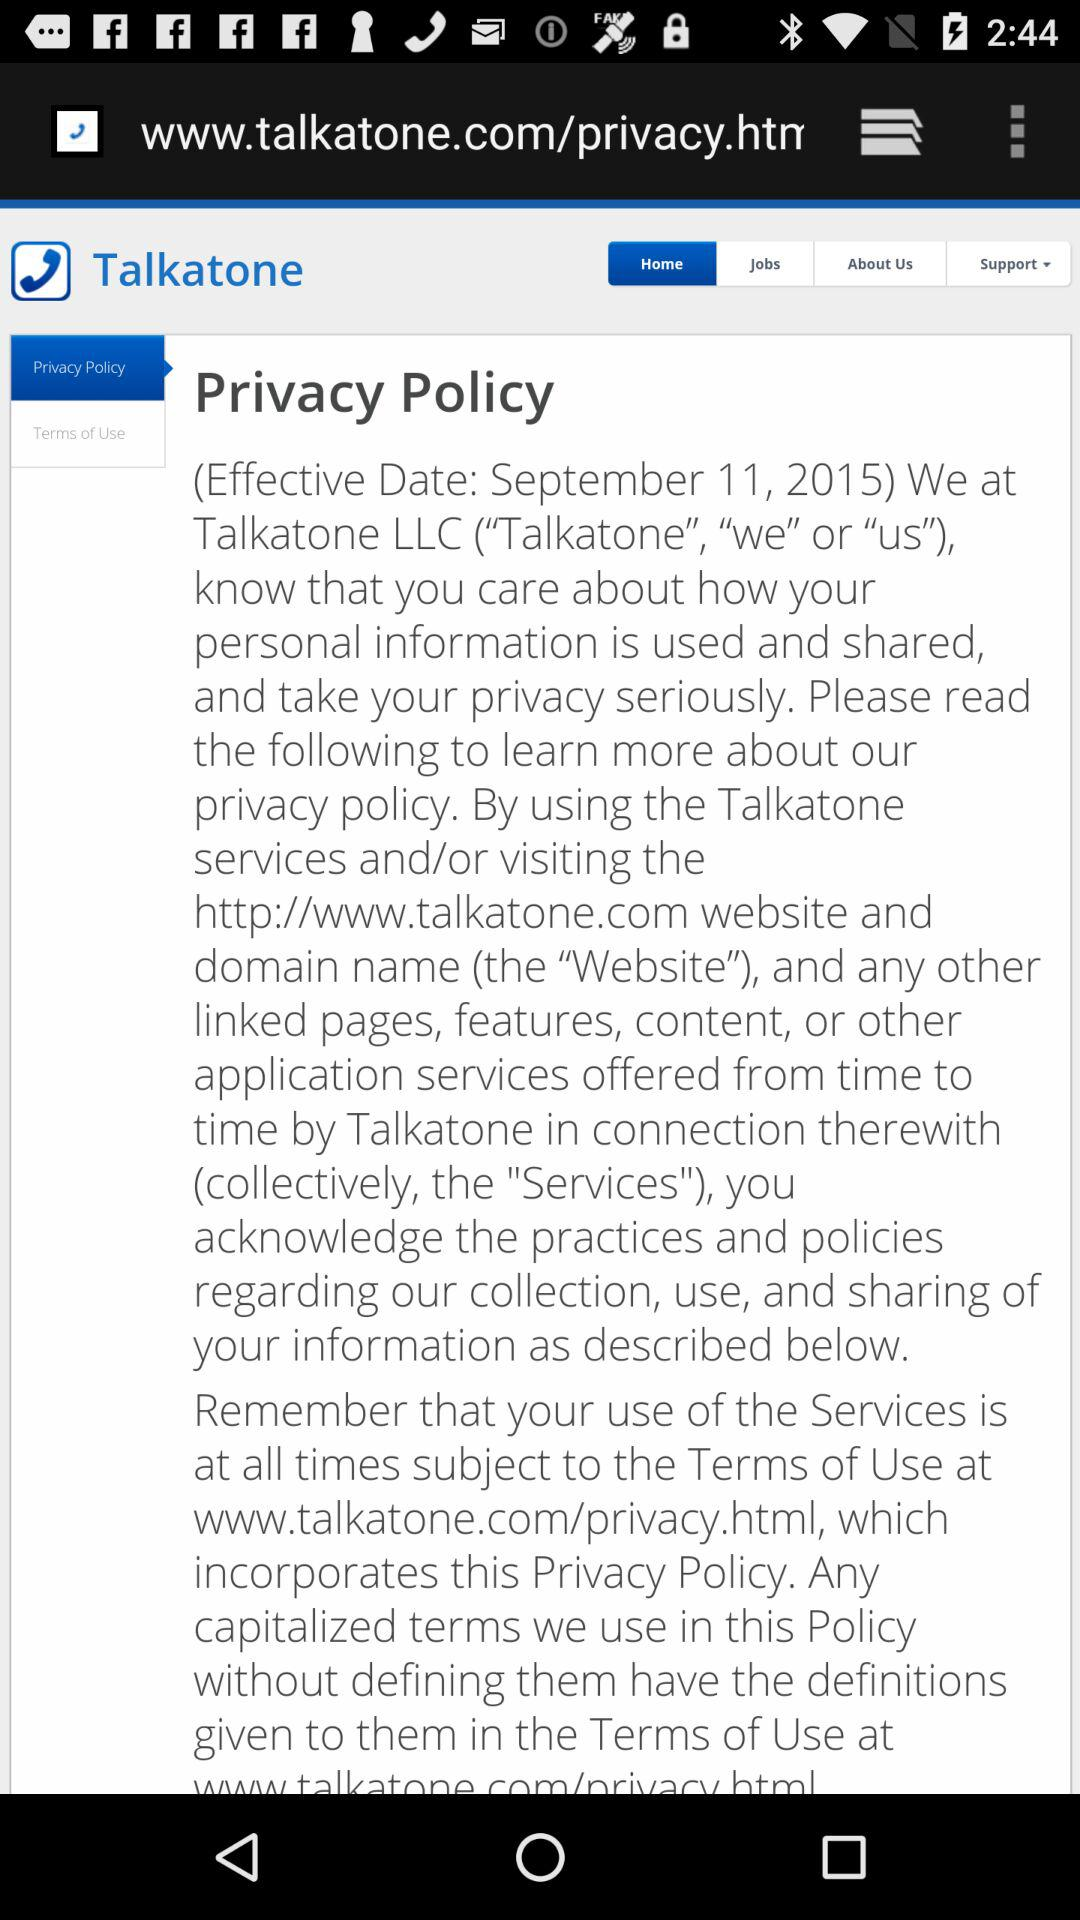Which option is selected? The selected options are "Home" and "Privacy Policy". 